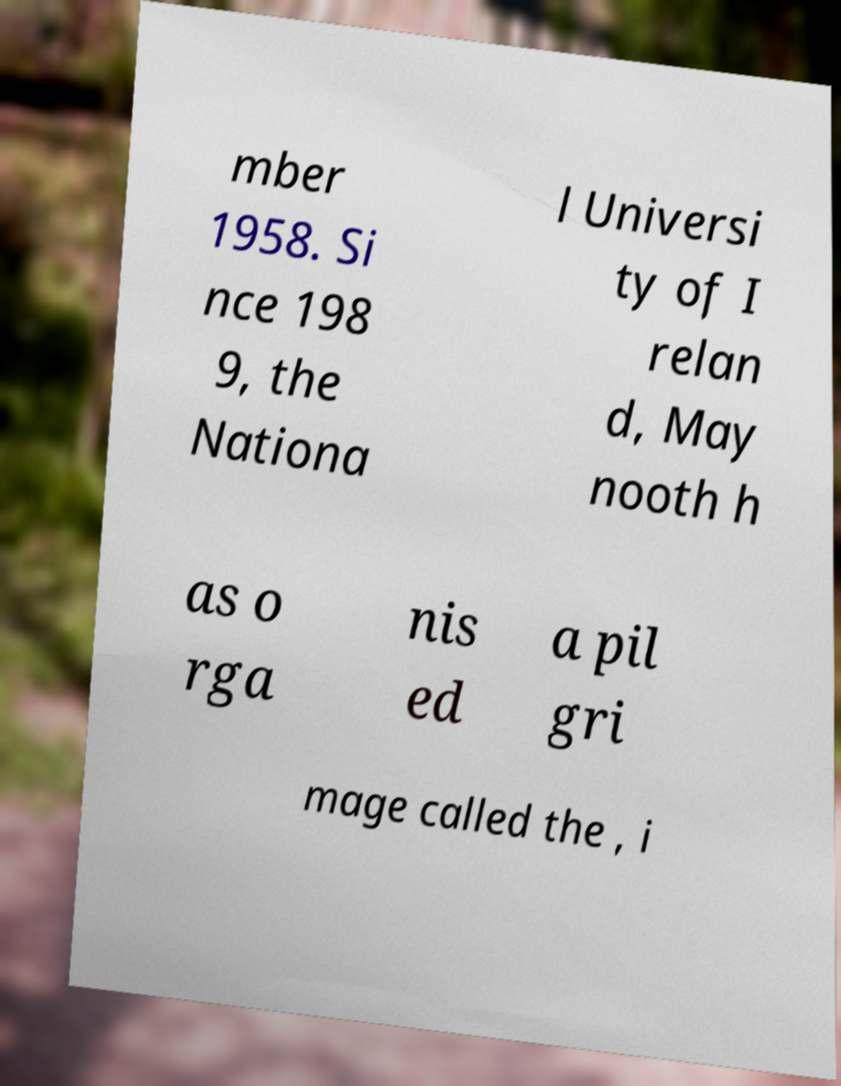For documentation purposes, I need the text within this image transcribed. Could you provide that? mber 1958. Si nce 198 9, the Nationa l Universi ty of I relan d, May nooth h as o rga nis ed a pil gri mage called the , i 